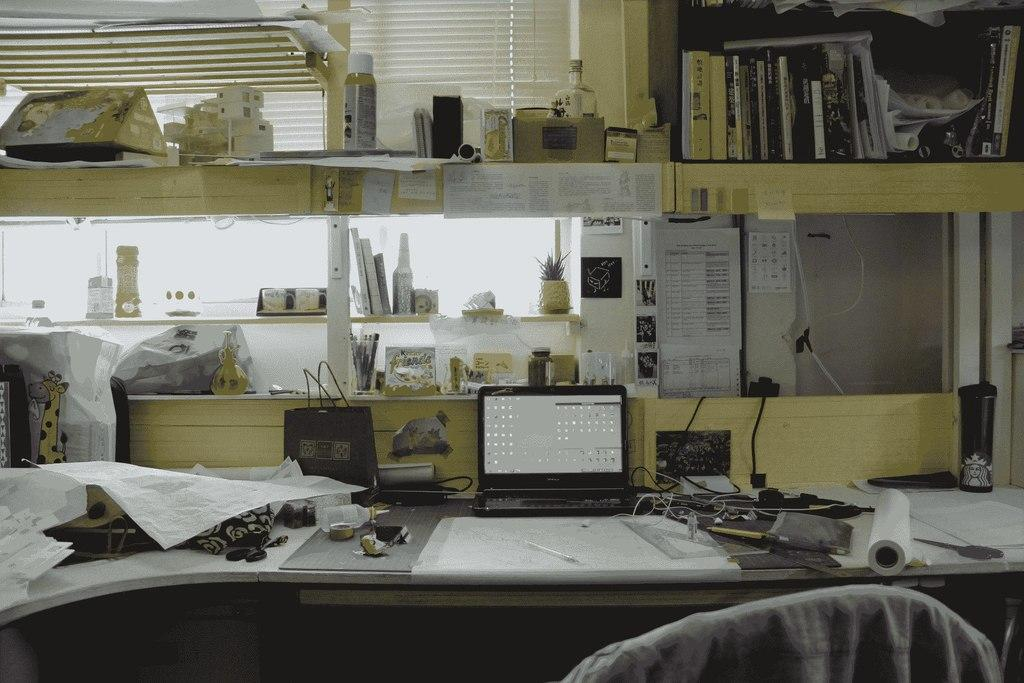What electronic device is visible in the image? There is a laptop in the image. What type of container is present in the image? There is a bottle in the image. What type of personal item is in the image? There is a bag in the image. What type of educational material is in the image? There are books in the image. What type of living organism is in the image? There is a plant in the image. What type of covering is in the image? There is a sheet in the image. What type of furniture is in the image? There is a chair in the image. What type of metal is used to make the teeth in the image? There are no teeth present in the image, and therefore no metal can be associated with them. How does the rainstorm affect the objects in the image? There is no rainstorm present in the image, so its effects cannot be observed. 